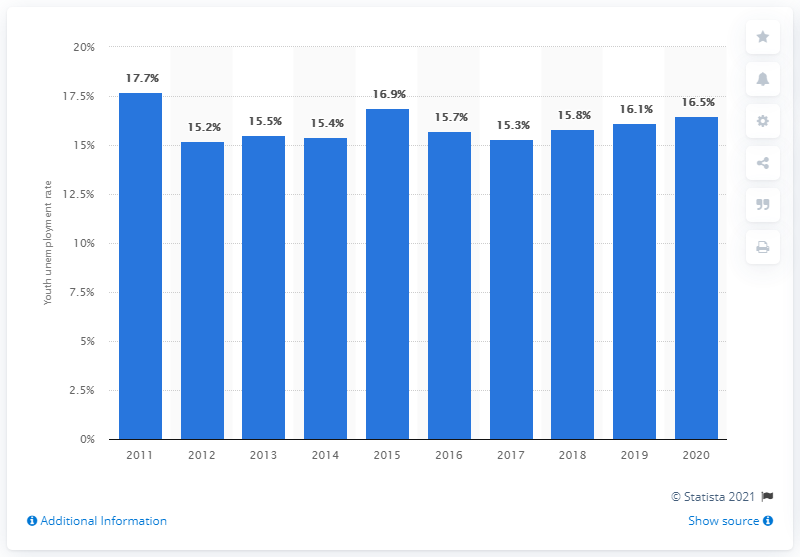Mention a couple of crucial points in this snapshot. Since 2018, the youth unemployment rate in Indonesia has been increasing. In 2020, the youth unemployment rate in Indonesia was 16.5%. 